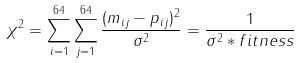<formula> <loc_0><loc_0><loc_500><loc_500>\chi ^ { 2 } = \sum _ { i = 1 } ^ { 6 4 } \sum _ { j = 1 } ^ { 6 4 } \frac { ( m _ { i j } - p _ { i j } ) ^ { 2 } } { \sigma ^ { 2 } } = \frac { 1 } { \sigma ^ { 2 } * f i t n e s s }</formula> 